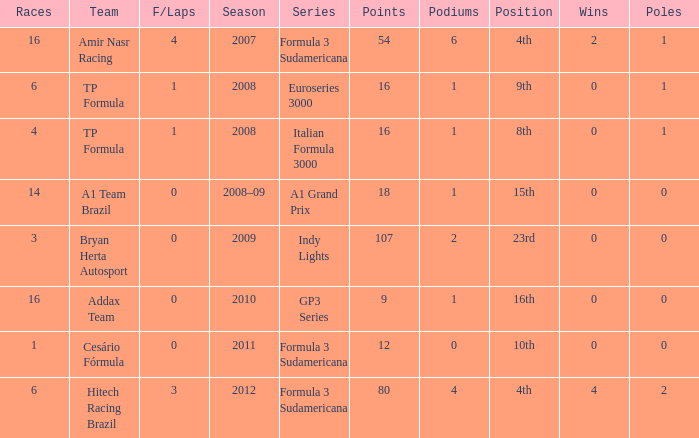What team did he compete for in the GP3 series? Addax Team. 